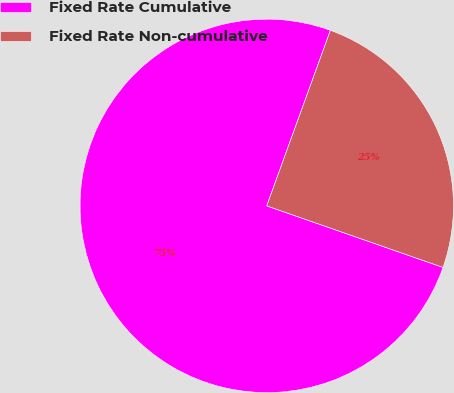<chart> <loc_0><loc_0><loc_500><loc_500><pie_chart><fcel>Fixed Rate Cumulative<fcel>Fixed Rate Non-cumulative<nl><fcel>75.19%<fcel>24.81%<nl></chart> 